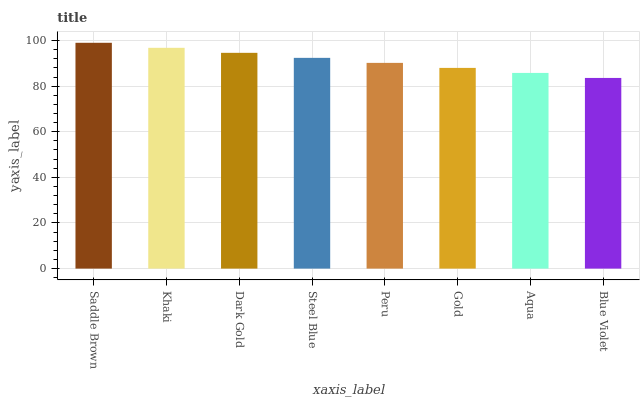Is Blue Violet the minimum?
Answer yes or no. Yes. Is Saddle Brown the maximum?
Answer yes or no. Yes. Is Khaki the minimum?
Answer yes or no. No. Is Khaki the maximum?
Answer yes or no. No. Is Saddle Brown greater than Khaki?
Answer yes or no. Yes. Is Khaki less than Saddle Brown?
Answer yes or no. Yes. Is Khaki greater than Saddle Brown?
Answer yes or no. No. Is Saddle Brown less than Khaki?
Answer yes or no. No. Is Steel Blue the high median?
Answer yes or no. Yes. Is Peru the low median?
Answer yes or no. Yes. Is Blue Violet the high median?
Answer yes or no. No. Is Saddle Brown the low median?
Answer yes or no. No. 